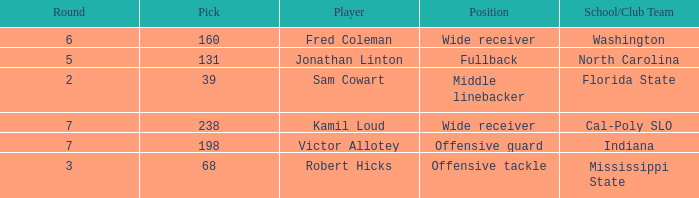Which Round has a School/Club Team of cal-poly slo, and a Pick smaller than 238? None. 